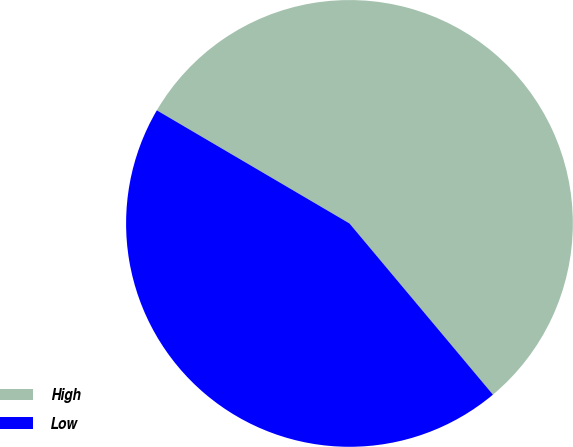Convert chart. <chart><loc_0><loc_0><loc_500><loc_500><pie_chart><fcel>High<fcel>Low<nl><fcel>55.45%<fcel>44.55%<nl></chart> 